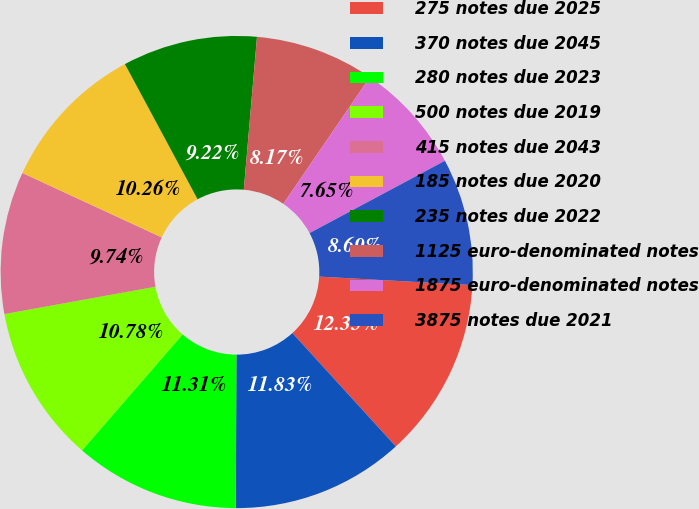Convert chart to OTSL. <chart><loc_0><loc_0><loc_500><loc_500><pie_chart><fcel>275 notes due 2025<fcel>370 notes due 2045<fcel>280 notes due 2023<fcel>500 notes due 2019<fcel>415 notes due 2043<fcel>185 notes due 2020<fcel>235 notes due 2022<fcel>1125 euro-denominated notes<fcel>1875 euro-denominated notes<fcel>3875 notes due 2021<nl><fcel>12.35%<fcel>11.83%<fcel>11.31%<fcel>10.78%<fcel>9.74%<fcel>10.26%<fcel>9.22%<fcel>8.17%<fcel>7.65%<fcel>8.69%<nl></chart> 